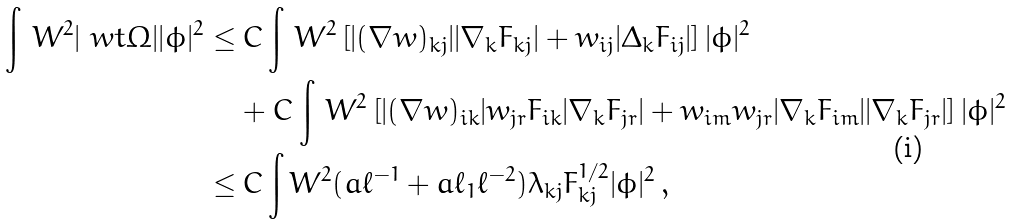<formula> <loc_0><loc_0><loc_500><loc_500>\int \, W ^ { 2 } | \ w t \Omega | | \phi | ^ { 2 } \leq & \, C \int \, W ^ { 2 } \left [ | ( \nabla w ) _ { k j } | | \nabla _ { k } F _ { k j } | + w _ { i j } | \Delta _ { k } F _ { i j } | \right ] | \phi | ^ { 2 } \\ & + C \int \, W ^ { 2 } \left [ | ( \nabla w ) _ { i k } | w _ { j r } F _ { i k } | \nabla _ { k } F _ { j r } | + w _ { i m } w _ { j r } | \nabla _ { k } F _ { i m } | | \nabla _ { k } F _ { j r } | \right ] | \phi | ^ { 2 } \\ \leq & \, C \int W ^ { 2 } ( a \ell ^ { - 1 } + a \ell _ { 1 } \ell ^ { - 2 } ) \lambda _ { k j } F _ { k j } ^ { 1 / 2 } | \phi | ^ { 2 } \, ,</formula> 